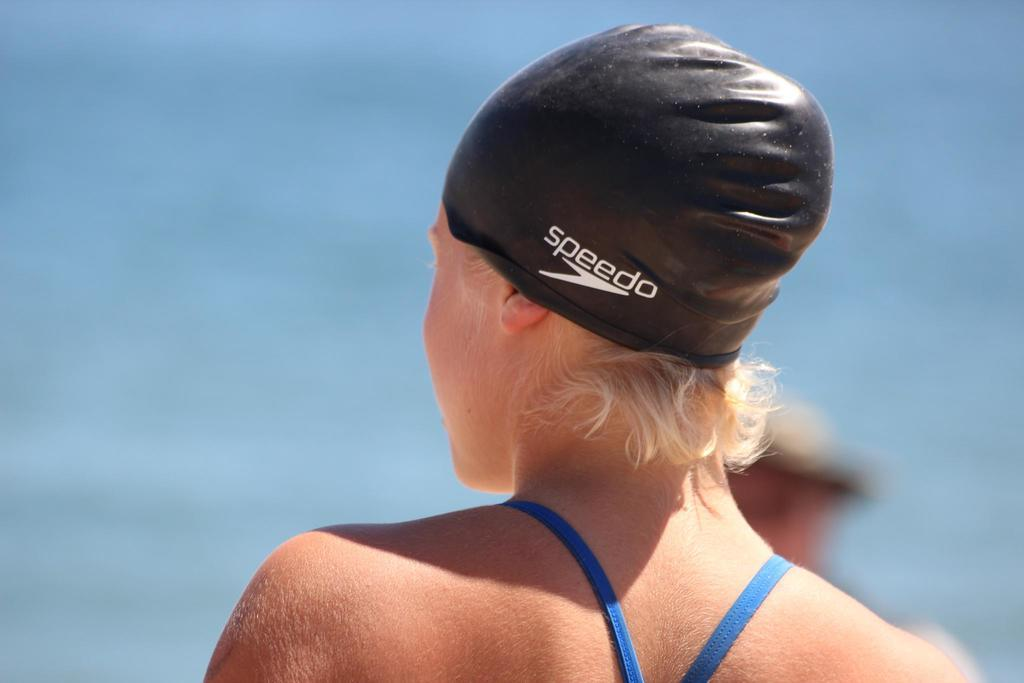What is the main subject of the image? There is a person in the image. What can be observed about the person's attire? The person is wearing a swimming cap. Can you describe the background of the image? The background of the image is blurred. What year is the swimming competition taking place in the image? There is no indication of a swimming competition or a specific year in the image. 